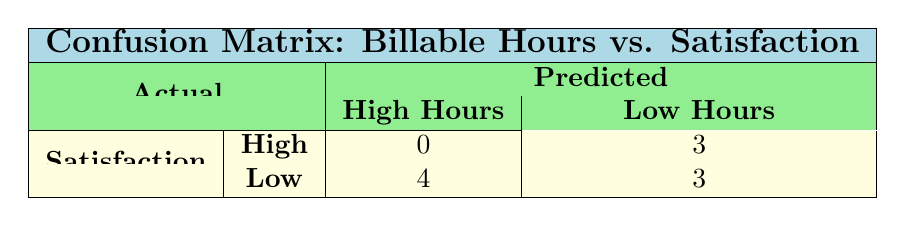What is the predicted count of clients with High satisfaction who worked Low billable hours? In the table, we look under the 'Predicted' column for 'Low Hours' and the 'Satisfaction' row for 'High'. The intersection gives us 3 clients.
Answer: 3 How many clients worked High billable hours? We check the 'Predicted' column for 'High Hours' under both satisfaction levels (High and Low). The 'High' satisfaction count is 0, and the 'Low' satisfaction count is 4. Adding these gives 0 + 4 = 4.
Answer: 4 What is the total number of clients with Low satisfaction? Looking at the 'Satisfaction' row for 'Low', we find 4 clients (3 from High Hours and 1 from Low Hours). Adding these clients gives us a total of 4 clients with Low satisfaction.
Answer: 4 Is it true that no clients with High satisfaction worked Low billable hours? In the 'Satisfaction' row for 'High', under the 'Predicted' column for 'Low Hours', we see the number is 3. Thus, the statement is false because there are clients who fit this description.
Answer: No What is the total count of clients with High satisfaction who also worked High billable hours? We look under the 'Predicted' column for 'High Hours' under the 'High' satisfaction row. It shows 0 as the count of clients. Therefore, the total is 0.
Answer: 0 How many more clients worked Low billable hours compared to those that worked High billable hours? First, we find the total number of clients who worked Low billable hours, which is 3 (High satisfaction) + 3 (Low satisfaction) = 6. For High billable hours, we already found 4 clients. The difference is 6 - 4 = 2.
Answer: 2 What is the total number of clients represented in this confusion matrix? To find the total number of clients, we add all the values in the matrix. This includes 0 (High satisfaction, High hours) + 3 (High satisfaction, Low hours) + 4 (Low satisfaction, High hours) + 3 (Low satisfaction, Low hours). Summing these gives us 0 + 3 + 4 + 3 = 10.
Answer: 10 Are there any clients with Medium satisfaction level represented in this table? The table only shows counts for High and Low satisfaction, so there are no clients with Medium satisfaction level represented. Therefore, the answer is true.
Answer: No What percentage of clients with Low hours are satisfied? There are 3 clients with High satisfaction and 3 with Low satisfaction under Low hours. Therefore, the total count for Low hours is 6 (3 from High + 3 from Low). For percentage, we compute (3 High satisfaction / 6 total) * 100 = 50%.
Answer: 50% 